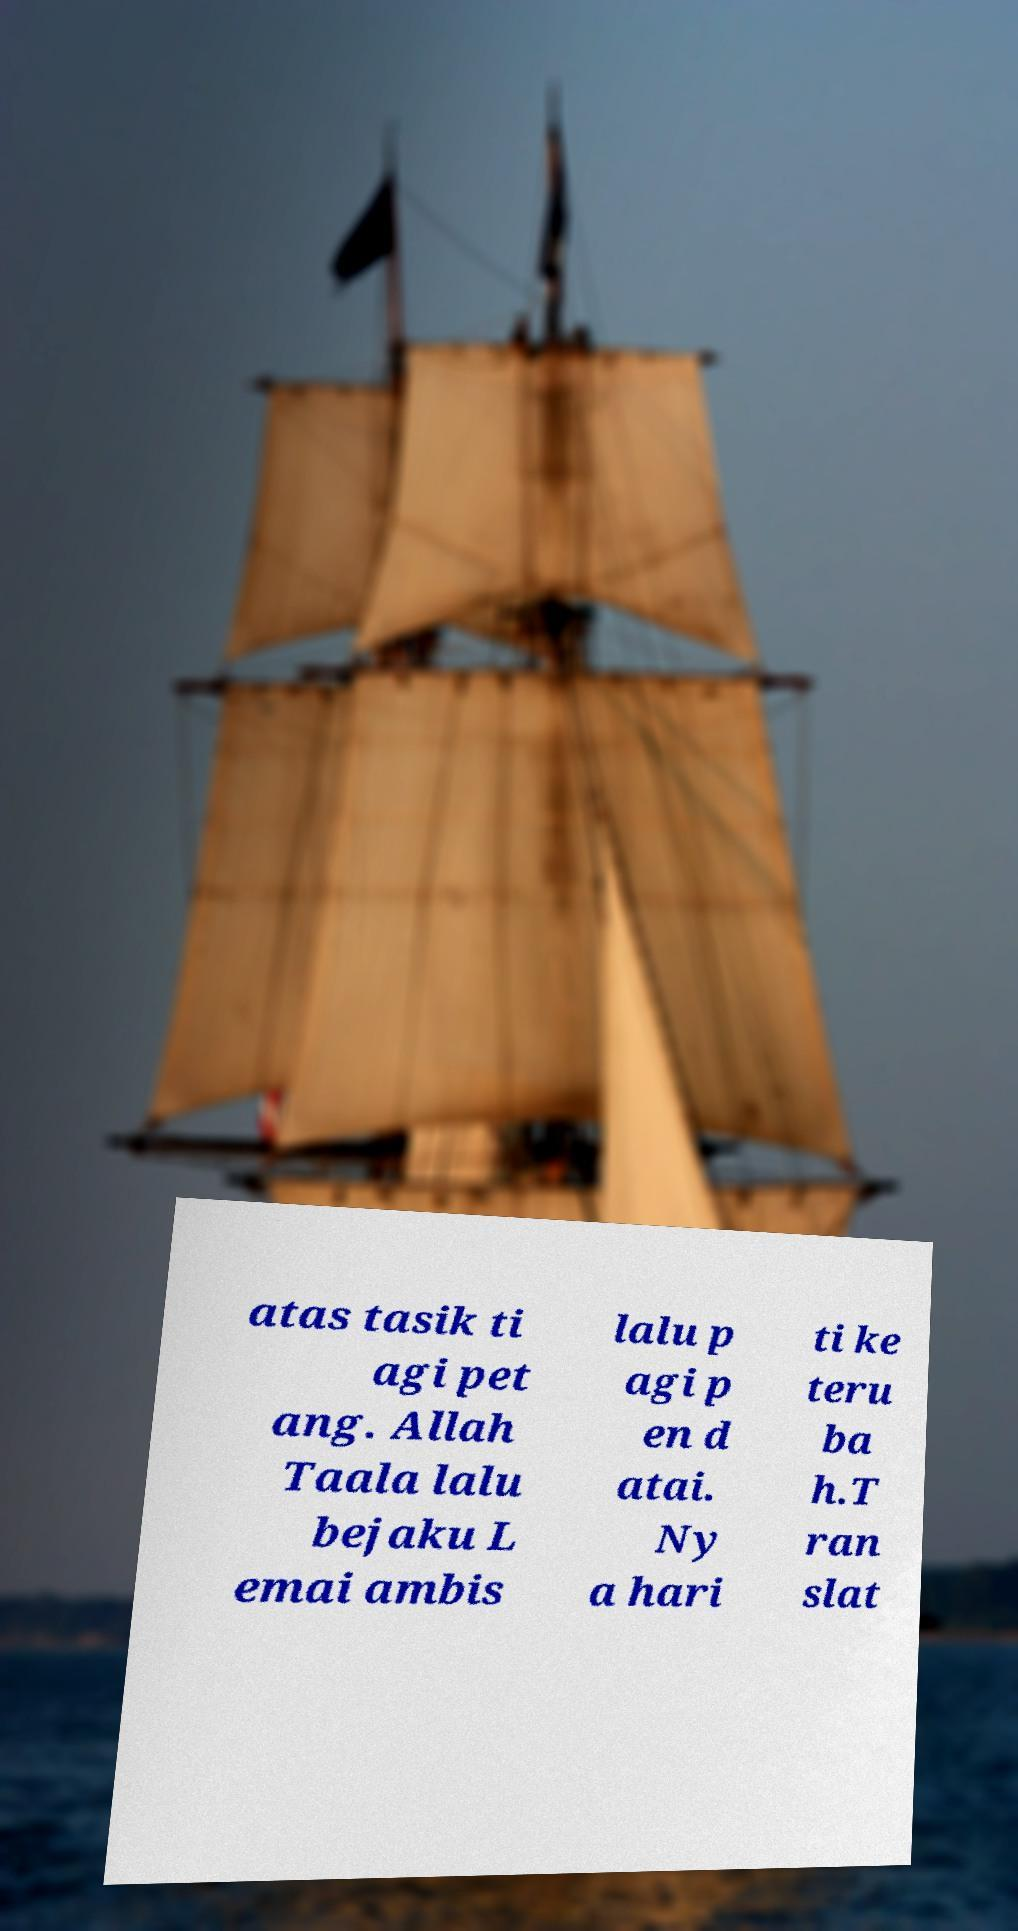I need the written content from this picture converted into text. Can you do that? atas tasik ti agi pet ang. Allah Taala lalu bejaku L emai ambis lalu p agi p en d atai. Ny a hari ti ke teru ba h.T ran slat 